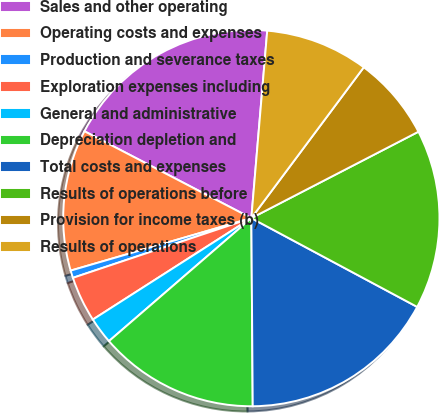Convert chart. <chart><loc_0><loc_0><loc_500><loc_500><pie_chart><fcel>Sales and other operating<fcel>Operating costs and expenses<fcel>Production and severance taxes<fcel>Exploration expenses including<fcel>General and administrative<fcel>Depreciation depletion and<fcel>Total costs and expenses<fcel>Results of operations before<fcel>Provision for income taxes (b)<fcel>Results of operations<nl><fcel>18.71%<fcel>12.14%<fcel>0.64%<fcel>3.92%<fcel>2.28%<fcel>13.78%<fcel>17.06%<fcel>15.42%<fcel>7.21%<fcel>8.85%<nl></chart> 